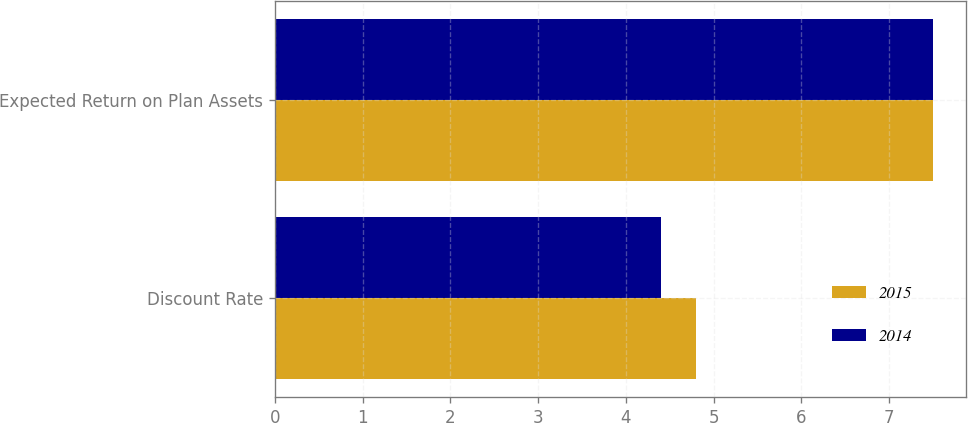Convert chart to OTSL. <chart><loc_0><loc_0><loc_500><loc_500><stacked_bar_chart><ecel><fcel>Discount Rate<fcel>Expected Return on Plan Assets<nl><fcel>2015<fcel>4.8<fcel>7.5<nl><fcel>2014<fcel>4.4<fcel>7.5<nl></chart> 